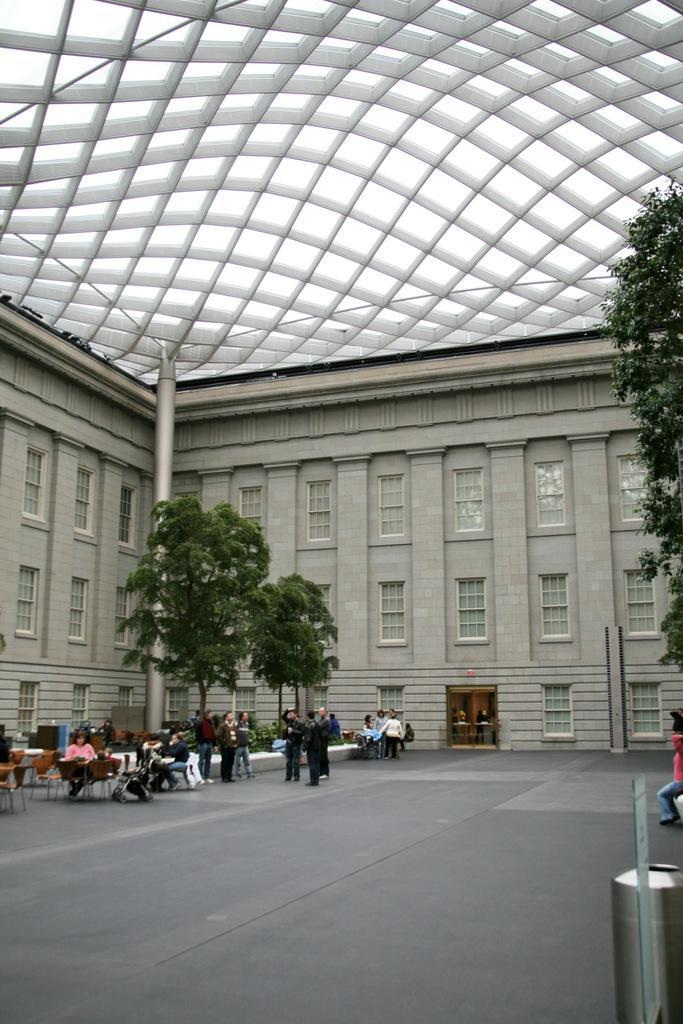Please provide a concise description of this image. In this image we can see a building with windows, pillars and a roof. We can also see a group of people on the floor. In that some are sitting on the chairs. On the right side we can see a container, a person sitting and some trees. 